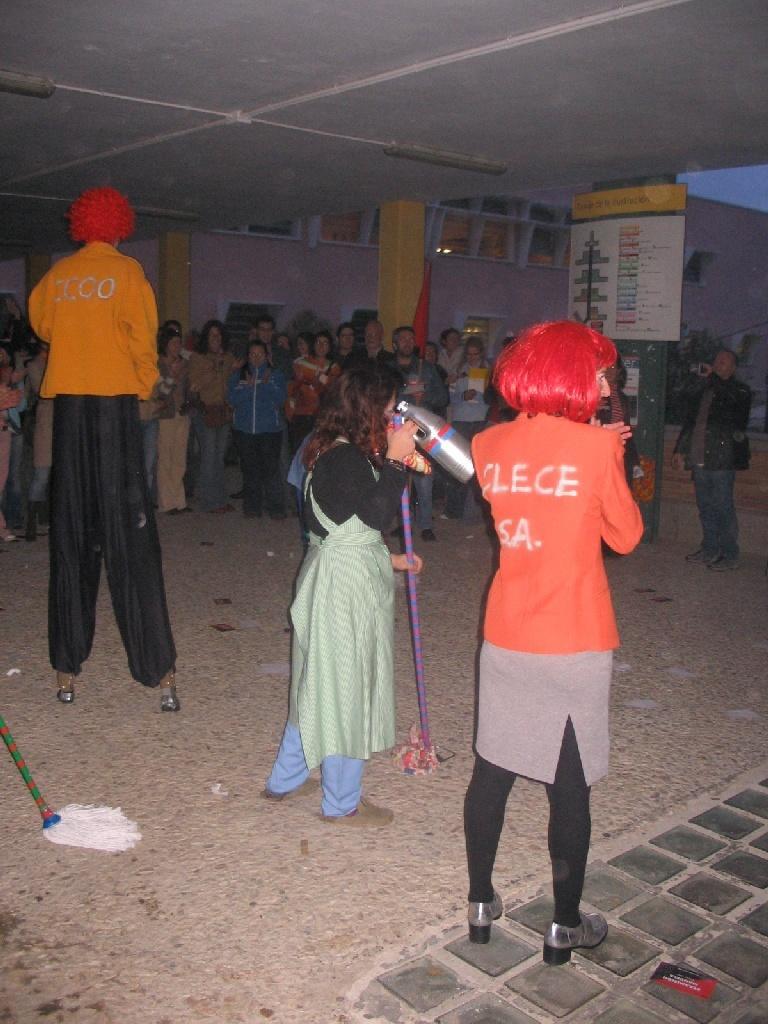How would you summarize this image in a sentence or two? There is a tall person, lady holding something and another person is standing. In the background there is a crowd. There are pillars and wall. And there is a poster in the background. 